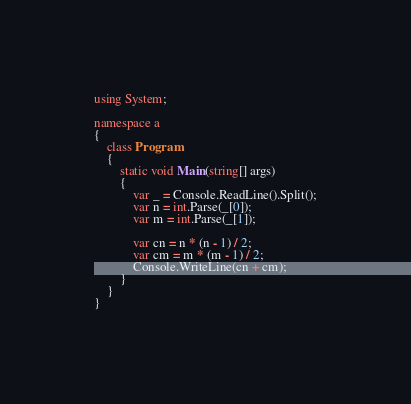<code> <loc_0><loc_0><loc_500><loc_500><_C#_>using System;

namespace a
{
    class Program
    {
        static void Main(string[] args)
        {
            var _ = Console.ReadLine().Split();
            var n = int.Parse(_[0]);
            var m = int.Parse(_[1]);

            var cn = n * (n - 1) / 2;
            var cm = m * (m - 1) / 2;
            Console.WriteLine(cn + cm);
        }
    }
}
</code> 